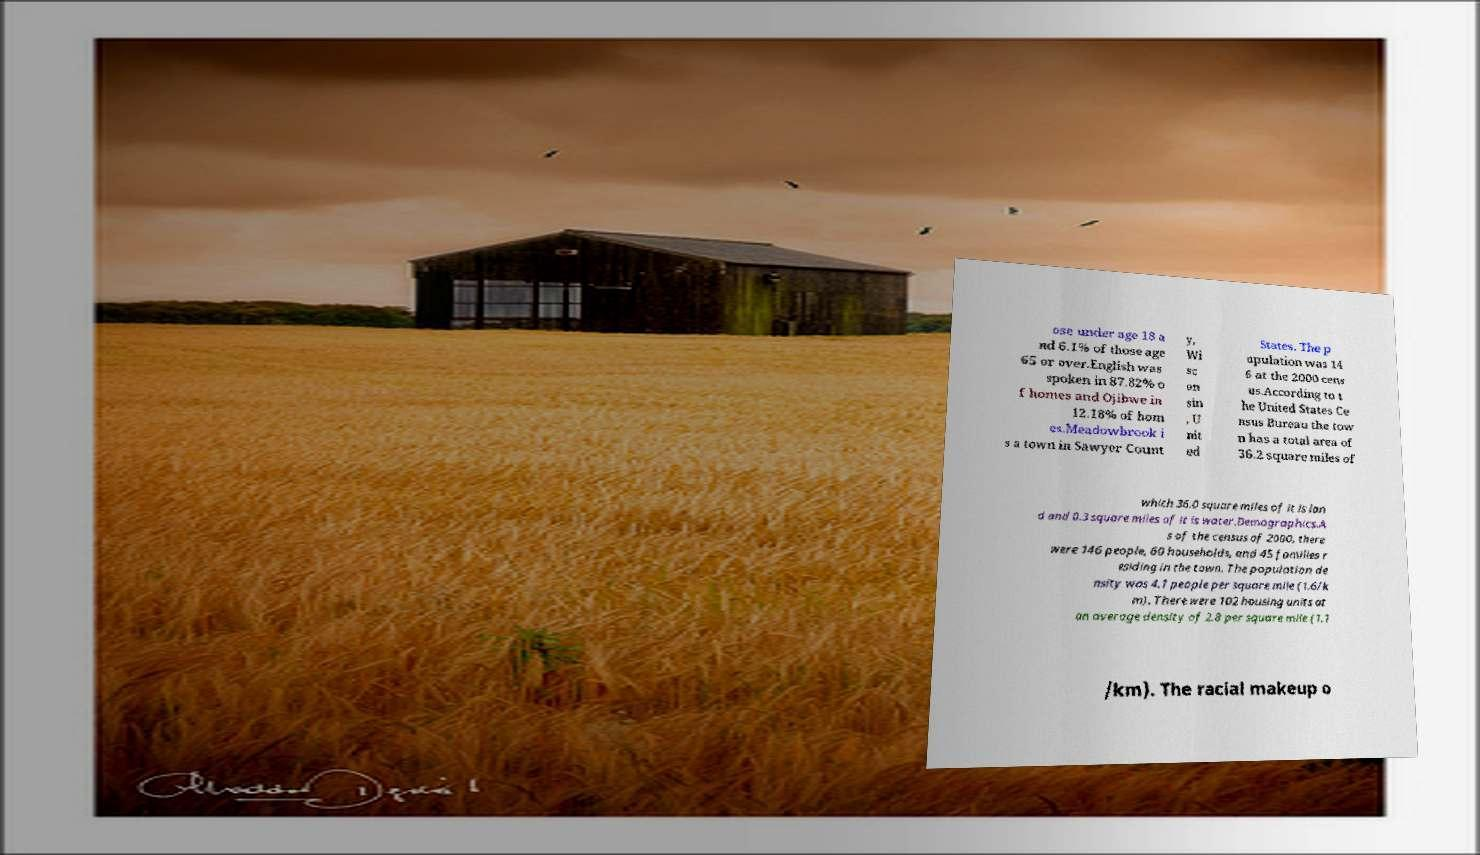Please identify and transcribe the text found in this image. ose under age 18 a nd 6.1% of those age 65 or over.English was spoken in 87.82% o f homes and Ojibwe in 12.18% of hom es.Meadowbrook i s a town in Sawyer Count y, Wi sc on sin , U nit ed States. The p opulation was 14 6 at the 2000 cens us.According to t he United States Ce nsus Bureau the tow n has a total area of 36.2 square miles of which 36.0 square miles of it is lan d and 0.3 square miles of it is water.Demographics.A s of the census of 2000, there were 146 people, 60 households, and 45 families r esiding in the town. The population de nsity was 4.1 people per square mile (1.6/k m). There were 102 housing units at an average density of 2.8 per square mile (1.1 /km). The racial makeup o 